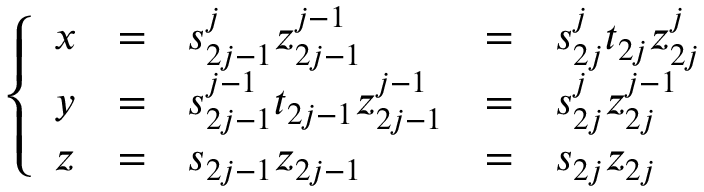Convert formula to latex. <formula><loc_0><loc_0><loc_500><loc_500>\left \{ \begin{array} { l c l c l } { x } & { = } & { { s _ { 2 j - 1 } ^ { j } z _ { 2 j - 1 } ^ { j - 1 } } } & { = } & { { s _ { 2 j } ^ { j } t _ { 2 j } z _ { 2 j } ^ { j } } } \\ { y } & { = } & { { s _ { 2 j - 1 } ^ { j - 1 } t _ { 2 j - 1 } z _ { 2 j - 1 } ^ { j - 1 } } } & { = } & { { s _ { 2 j } ^ { j } z _ { 2 j } ^ { j - 1 } } } \\ { z } & { = } & { { s _ { 2 j - 1 } z _ { 2 j - 1 } } } & { = } & { { s _ { 2 j } z _ { 2 j } } } \end{array}</formula> 